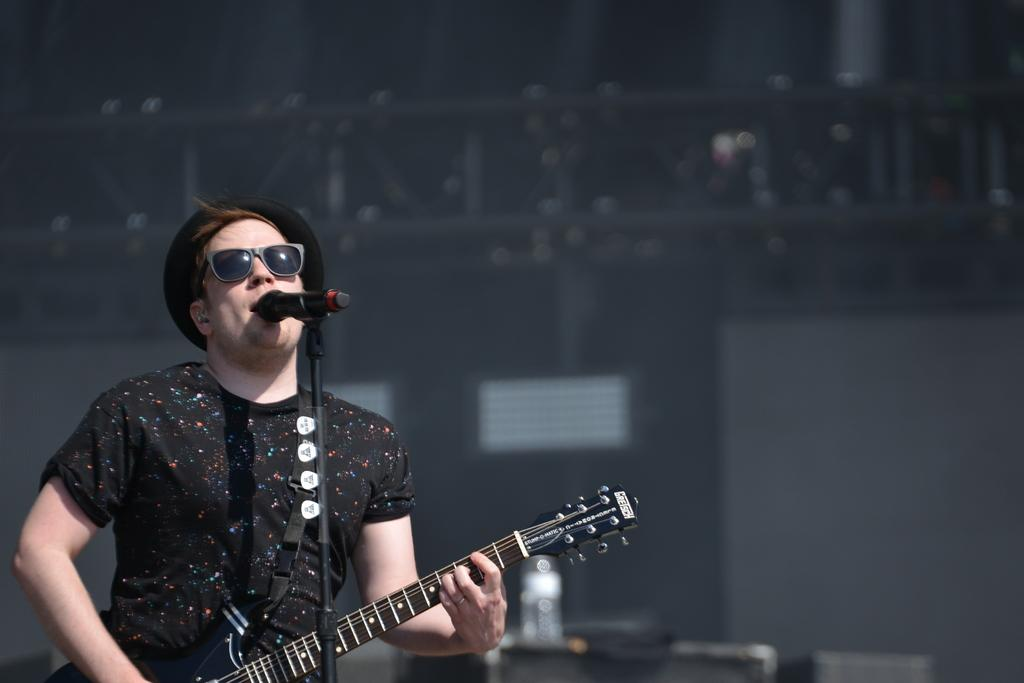What is the person in the image doing? The person is holding a guitar and singing. What object is the person using to amplify their voice? There is a microphone with a stand in the image. What type of headwear is the person wearing? The person is wearing a cap. How much sugar is being traded in the image? There is no reference to sugar or trade in the image; it features a person singing with a guitar and a microphone. 